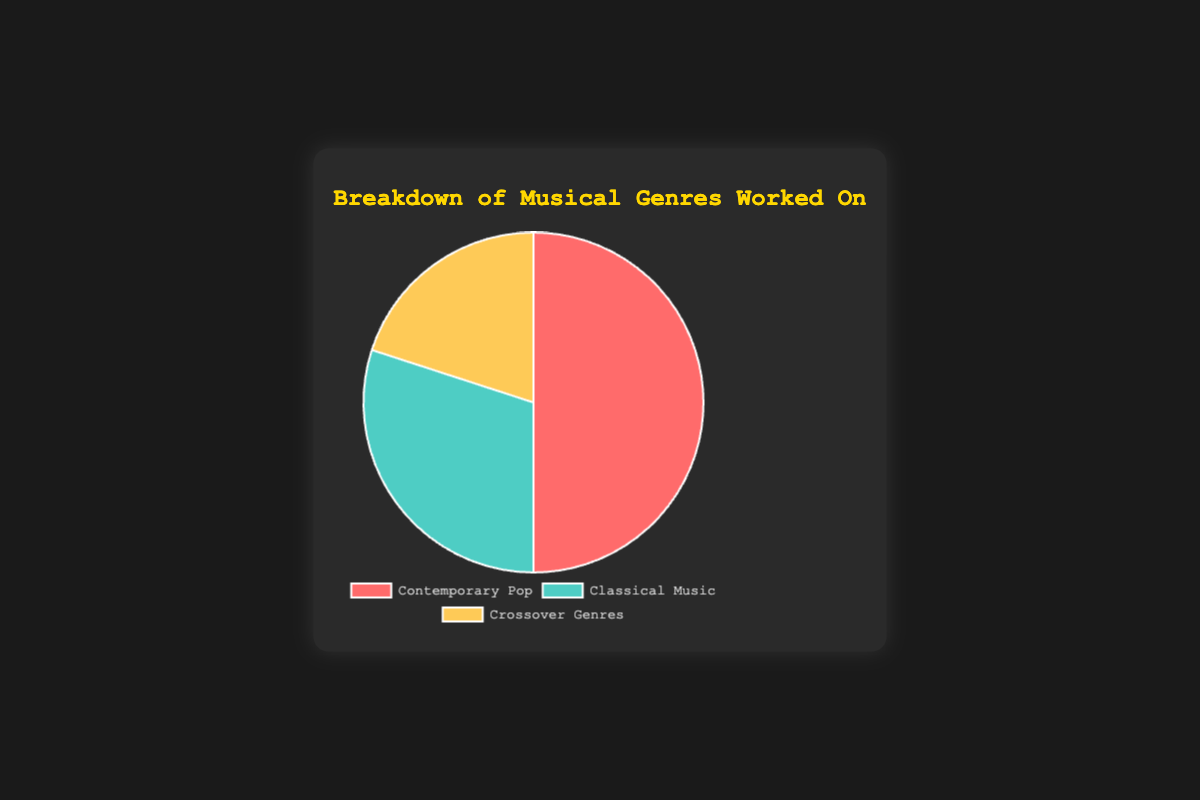What percentage of genres worked on is not contemporary pop? To find the percentage of genres that are not contemporary pop, we add the percentage of classical music and crossover genres. Classical music is 30% and crossover genres are 20%. So, 30% + 20% = 50%.
Answer: 50% Which genre has the highest percentage? By comparing the percentages, we see that contemporary pop has 50%, classical music has 30%, and crossover genres have 20%. The highest percentage is 50%, which belongs to contemporary pop.
Answer: Contemporary Pop What is the smallest genre worked on, and what is its percentage? By visual inspection, the genre with the smallest segment in the pie chart is the crossover genres, which has a percentage of 20%.
Answer: Crossover Genres, 20% Is the percentage of classical music more than crossover genres? Comparing the two percentages, classical music has 30% and crossover genres have 20%. 30% is greater than 20%.
Answer: Yes What is the total percentage of crossover genres and contemporary pop? Adding the percentages of crossover genres (20%) and contemporary pop (50%), we get 20% + 50% = 70%.
Answer: 70% Which genre has a segment with the blueish color? By observing the colors used in the pie chart, the segment with the blueish color represents classical music.
Answer: Classical Music How much more is the percentage of contemporary pop compared to classical music? To find how much more contemporary pop is compared to classical music, subtract the percentage of classical music from contemporary pop: 50% - 30% = 20%.
Answer: 20% By how much do crossover genres make up a smaller percentage than classical music? Subtract the percentage of crossover genres from the percentage of classical music: 30% - 20% = 10%.
Answer: 10% Are the combined percentages of classical and crossover genres equal to the percentage of contemporary pop? Adding the percentages of classical music (30%) and crossover genres (20%), we get 30% + 20% = 50%, which is equal to the percentage of contemporary pop.
Answer: Yes 